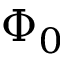Convert formula to latex. <formula><loc_0><loc_0><loc_500><loc_500>\Phi _ { 0 }</formula> 